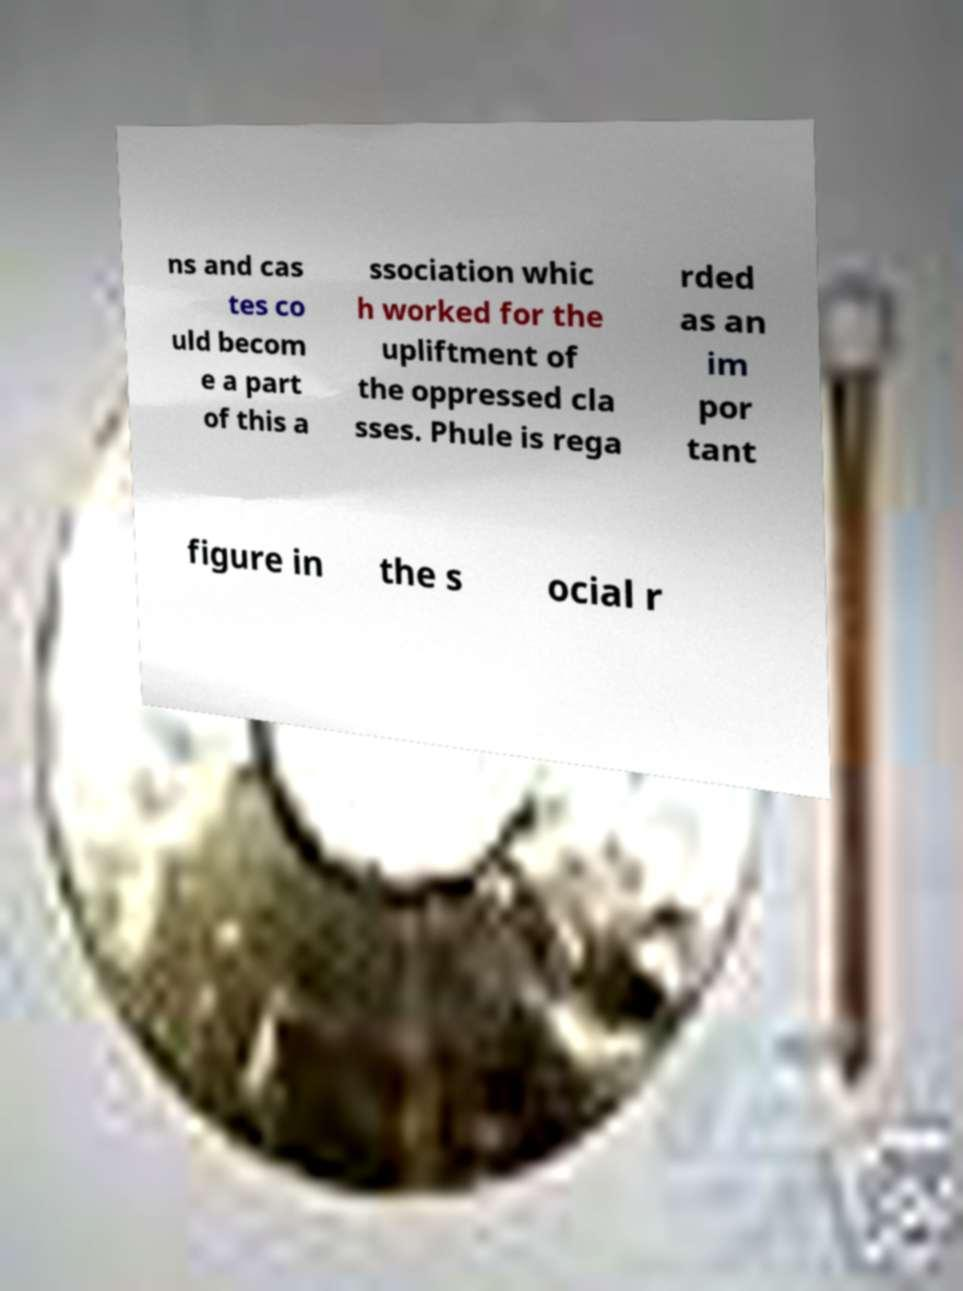Could you extract and type out the text from this image? ns and cas tes co uld becom e a part of this a ssociation whic h worked for the upliftment of the oppressed cla sses. Phule is rega rded as an im por tant figure in the s ocial r 